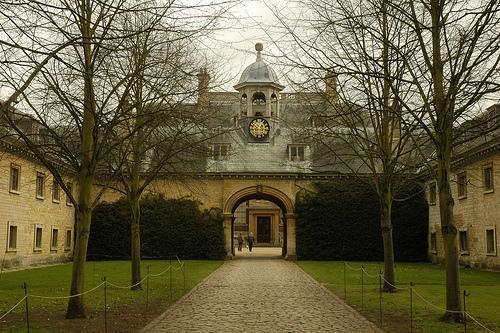How many bell towers?
Give a very brief answer. 1. How many archs?
Give a very brief answer. 1. How many trees?
Give a very brief answer. 4. 